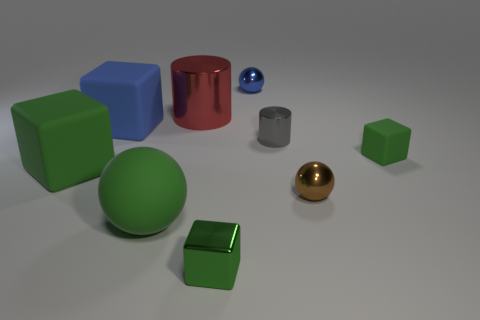What number of other objects are the same material as the big red cylinder?
Provide a succinct answer. 4. What material is the green ball that is the same size as the blue block?
Provide a short and direct response. Rubber. How many green objects are either cubes or big cylinders?
Your response must be concise. 3. There is a block that is on the right side of the large matte ball and left of the small green matte block; what is its color?
Keep it short and to the point. Green. Does the tiny gray cylinder to the right of the green rubber ball have the same material as the small green cube behind the brown sphere?
Offer a very short reply. No. Are there more small brown shiny spheres that are right of the big blue thing than brown shiny balls that are in front of the brown ball?
Make the answer very short. Yes. What shape is the green object that is the same size as the green matte ball?
Provide a short and direct response. Cube. What number of things are either cyan spheres or green rubber things that are left of the small gray cylinder?
Offer a terse response. 2. Do the small shiny block and the rubber ball have the same color?
Offer a very short reply. Yes. How many green objects are to the right of the tiny blue metallic ball?
Offer a terse response. 1. 